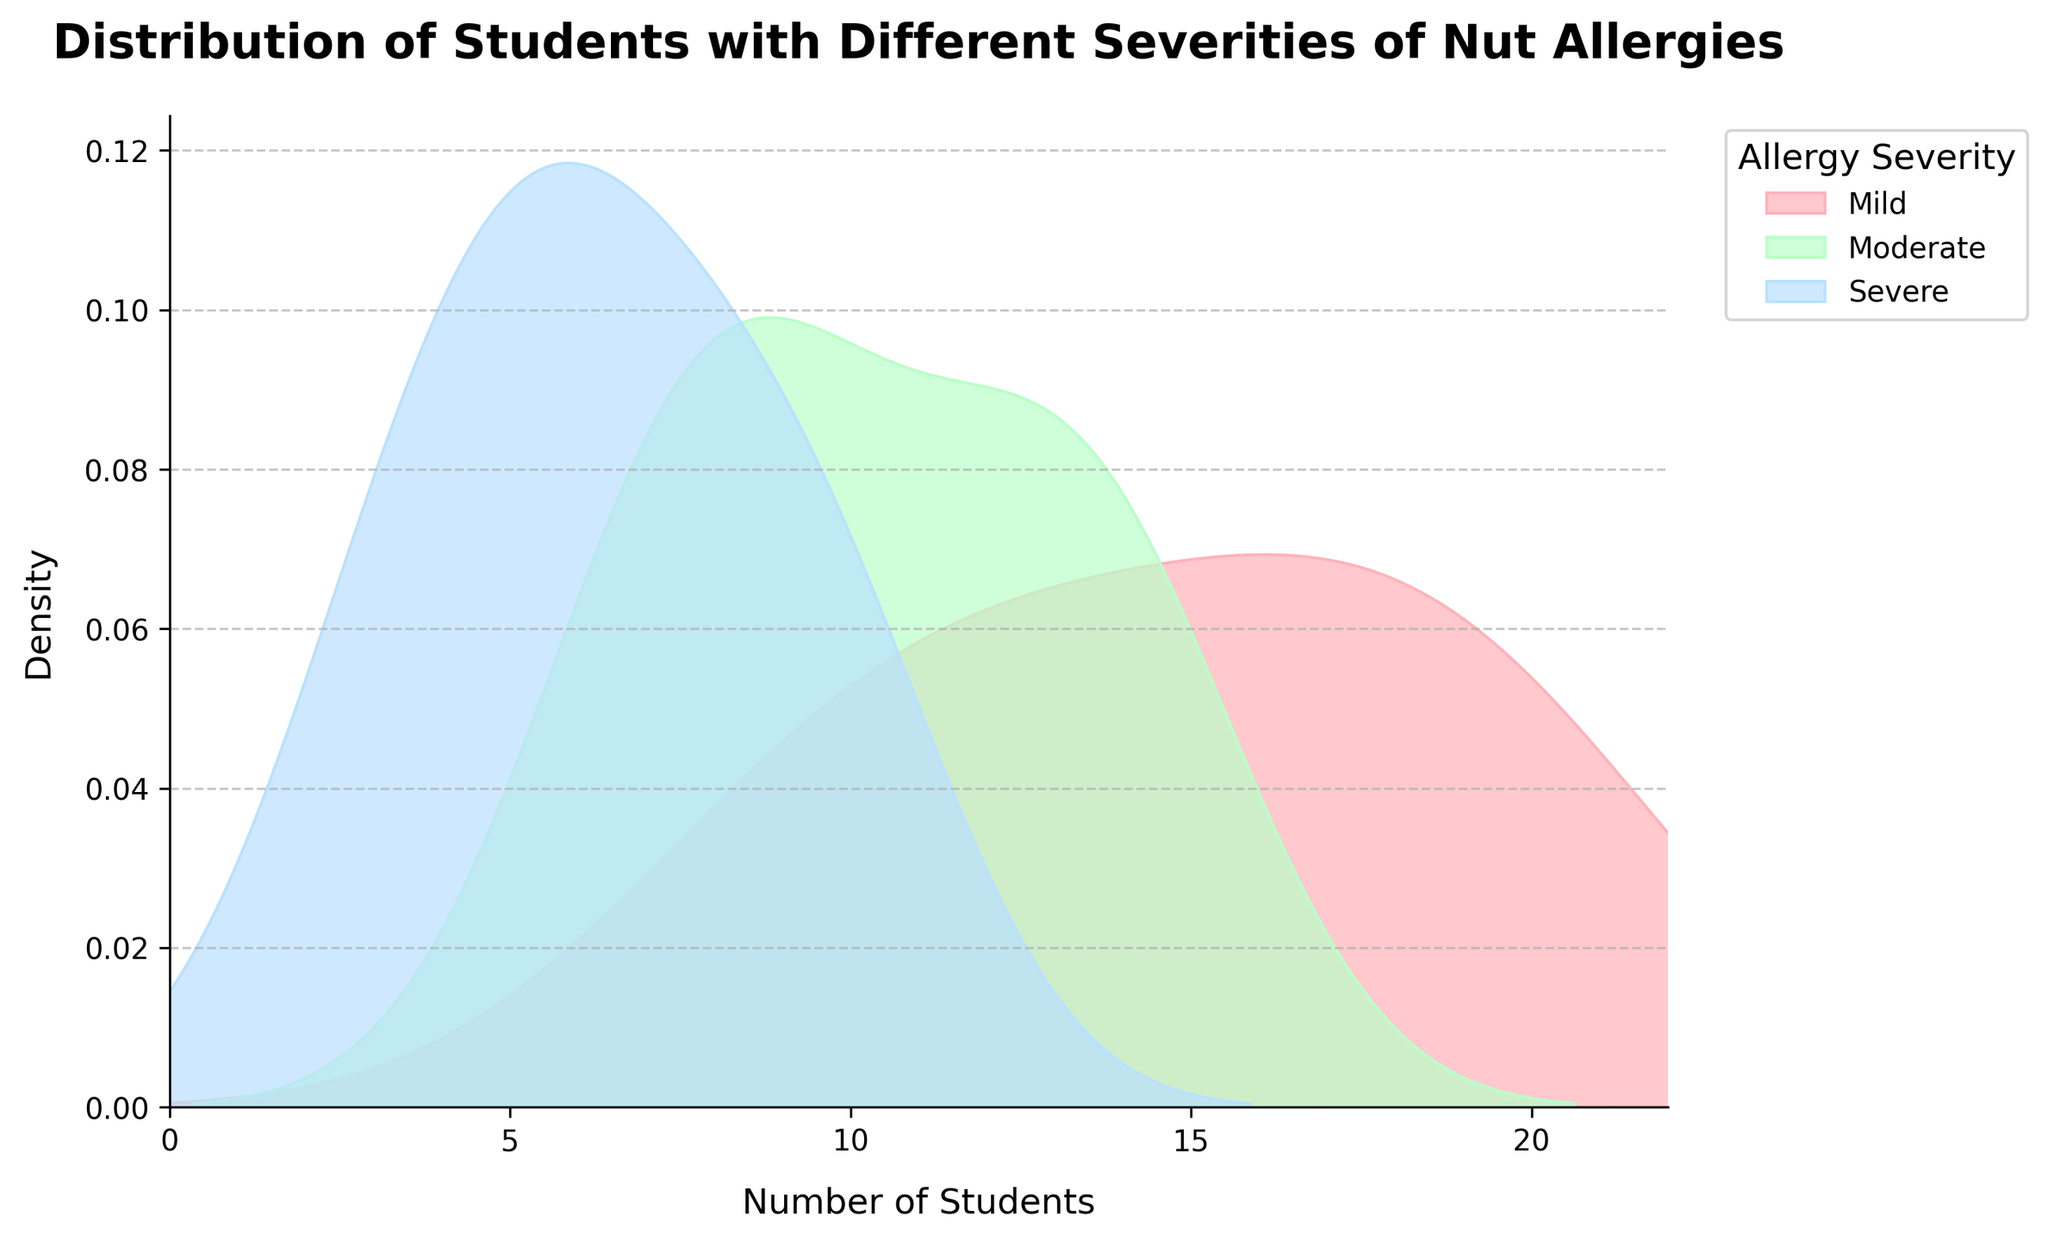What is the title of the plot? The title is displayed at the top of the plot and gives an overview of what the plot is representing. By looking at the top, we can see that the title is "Distribution of Students with Different Severities of Nut Allergies".
Answer: `Distribution of Students with Different Severities of Nut Allergies` What is the x-axis labeled? The x-axis label provides information on what the x-axis represents. In the plot, the x-axis is labeled as "Number of Students".
Answer: `Number of Students` What are the three colors used in the distplot? The colors help differentiate between the levels of allergy severity. By looking at the plot, we can identify the three colors as light pink, light green, and light blue.
Answer: `Light pink, light green, light blue` Which severity group has the highest peak density? The peak density indicates the most frequent occurrence within a group. By examining the density peaks, it's clear that the mild severity group has the highest peak density.
Answer: `Mild` What is the approximate range of the number of students with moderate nut allergies? The range indicates the spread of the data. By looking at the width of the moderate density curve on the x-axis, we can see it spans from about 7 to 14.
Answer: `7 to 14` What is the median number of students with severe nut allergies? The median is the middle value when the data is sorted. The severe group density peak suggests that the median value lies around the highest peak, which is approximately 6-8.
Answer: `6-8` Which severity group has the widest distribution? The width of the distribution curve indicates how spread out the values are. The mild group has the widest spread, from approximately 9 to 20 on the x-axis.
Answer: `Mild` Compare the peak densities of mild and severe groups: Which is higher? Comparing the peaks of the density curves for mild and severe groups, the mild group has a higher peak density than the severe group.
Answer: `Mild` How do the number of students in moderate and severe severity groups compare at the lower end of their distributions? At the lower end of the distribution curves, we see that moderate densities start around 7, while severe starts around 3. So the severe group starts at a lower number of students.
Answer: `Severe starts lower` Do any of the severity groups overlap in their distributions? Looking at the distribution curves on the plot, the distributions of the mild and moderate groups overlap somewhat around the 10-13 range, while the severe group is generally separate.
Answer: `Yes, mild and moderate overlap` 